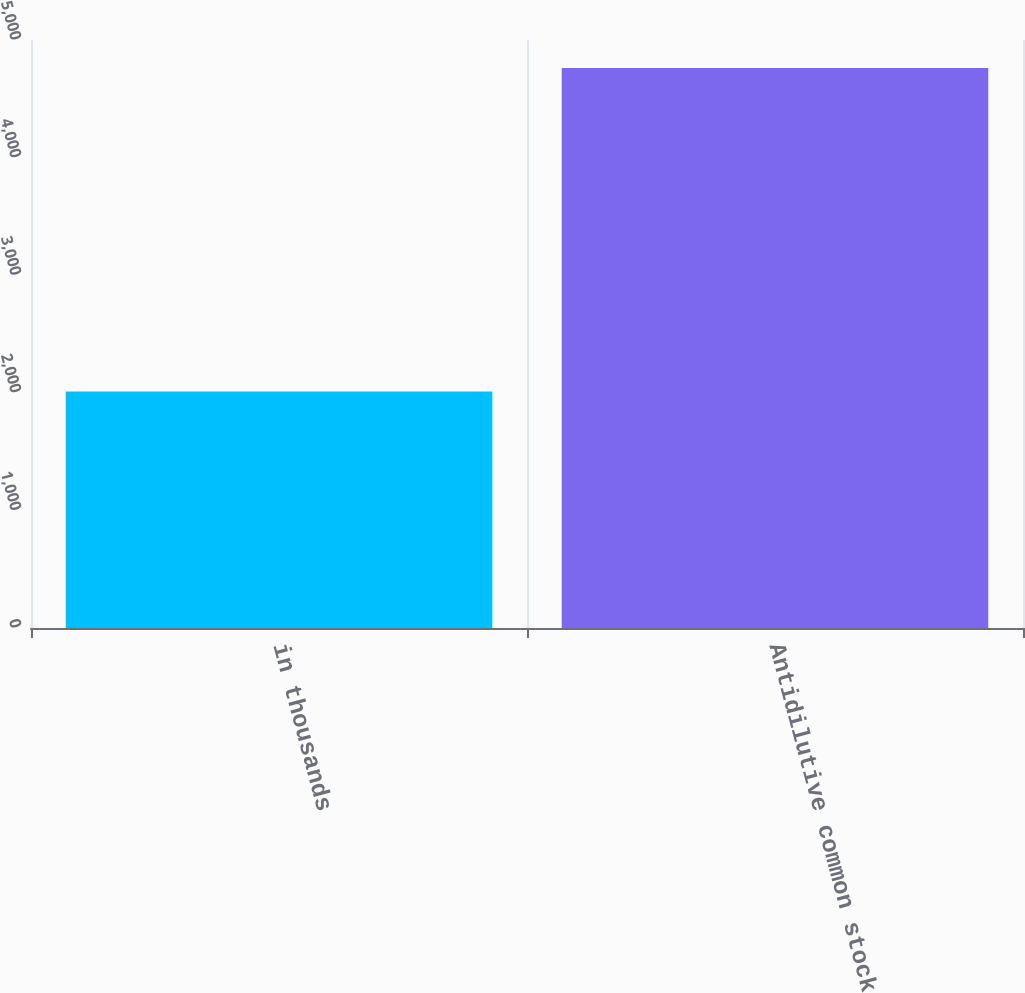Convert chart. <chart><loc_0><loc_0><loc_500><loc_500><bar_chart><fcel>in thousands<fcel>Antidilutive common stock<nl><fcel>2012<fcel>4762<nl></chart> 